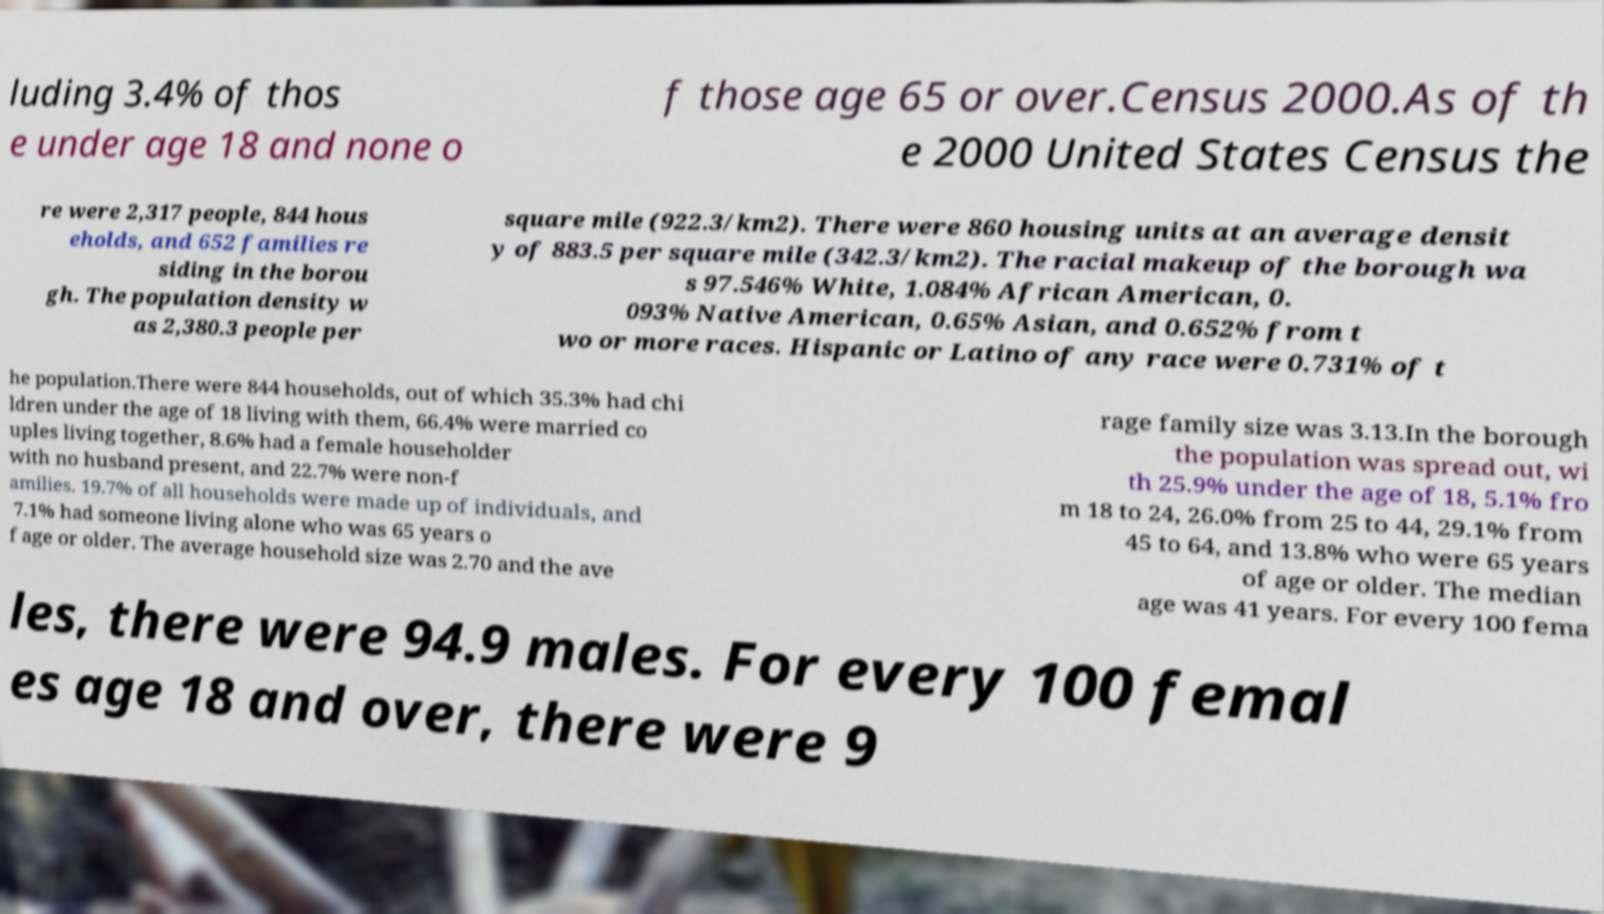Please identify and transcribe the text found in this image. luding 3.4% of thos e under age 18 and none o f those age 65 or over.Census 2000.As of th e 2000 United States Census the re were 2,317 people, 844 hous eholds, and 652 families re siding in the borou gh. The population density w as 2,380.3 people per square mile (922.3/km2). There were 860 housing units at an average densit y of 883.5 per square mile (342.3/km2). The racial makeup of the borough wa s 97.546% White, 1.084% African American, 0. 093% Native American, 0.65% Asian, and 0.652% from t wo or more races. Hispanic or Latino of any race were 0.731% of t he population.There were 844 households, out of which 35.3% had chi ldren under the age of 18 living with them, 66.4% were married co uples living together, 8.6% had a female householder with no husband present, and 22.7% were non-f amilies. 19.7% of all households were made up of individuals, and 7.1% had someone living alone who was 65 years o f age or older. The average household size was 2.70 and the ave rage family size was 3.13.In the borough the population was spread out, wi th 25.9% under the age of 18, 5.1% fro m 18 to 24, 26.0% from 25 to 44, 29.1% from 45 to 64, and 13.8% who were 65 years of age or older. The median age was 41 years. For every 100 fema les, there were 94.9 males. For every 100 femal es age 18 and over, there were 9 